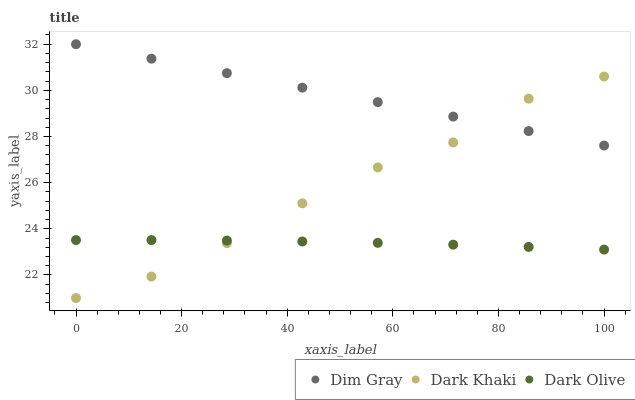Does Dark Olive have the minimum area under the curve?
Answer yes or no. Yes. Does Dim Gray have the maximum area under the curve?
Answer yes or no. Yes. Does Dim Gray have the minimum area under the curve?
Answer yes or no. No. Does Dark Olive have the maximum area under the curve?
Answer yes or no. No. Is Dim Gray the smoothest?
Answer yes or no. Yes. Is Dark Khaki the roughest?
Answer yes or no. Yes. Is Dark Olive the smoothest?
Answer yes or no. No. Is Dark Olive the roughest?
Answer yes or no. No. Does Dark Khaki have the lowest value?
Answer yes or no. Yes. Does Dark Olive have the lowest value?
Answer yes or no. No. Does Dim Gray have the highest value?
Answer yes or no. Yes. Does Dark Olive have the highest value?
Answer yes or no. No. Is Dark Olive less than Dim Gray?
Answer yes or no. Yes. Is Dim Gray greater than Dark Olive?
Answer yes or no. Yes. Does Dark Olive intersect Dark Khaki?
Answer yes or no. Yes. Is Dark Olive less than Dark Khaki?
Answer yes or no. No. Is Dark Olive greater than Dark Khaki?
Answer yes or no. No. Does Dark Olive intersect Dim Gray?
Answer yes or no. No. 